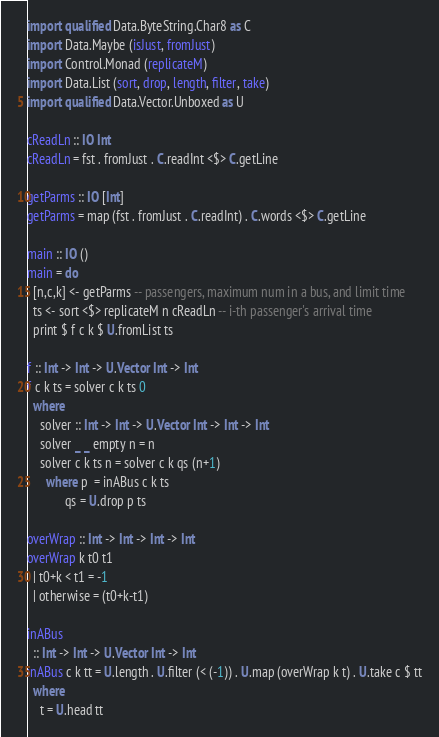Convert code to text. <code><loc_0><loc_0><loc_500><loc_500><_Haskell_>import qualified Data.ByteString.Char8 as C
import Data.Maybe (isJust, fromJust)
import Control.Monad (replicateM)
import Data.List (sort, drop, length, filter, take)
import qualified Data.Vector.Unboxed as U

cReadLn :: IO Int
cReadLn = fst . fromJust . C.readInt <$> C.getLine

getParms :: IO [Int]
getParms = map (fst . fromJust . C.readInt) . C.words <$> C.getLine

main :: IO ()
main = do
  [n,c,k] <- getParms -- passengers, maximum num in a bus, and limit time
  ts <- sort <$> replicateM n cReadLn -- i-th passenger's arrival time
  print $ f c k $ U.fromList ts

f :: Int -> Int -> U.Vector Int -> Int
f c k ts = solver c k ts 0
  where
    solver :: Int -> Int -> U.Vector Int -> Int -> Int
    solver _ _ empty n = n
    solver c k ts n = solver c k qs (n+1)
      where p  = inABus c k ts
            qs = U.drop p ts

overWrap :: Int -> Int -> Int -> Int
overWrap k t0 t1
  | t0+k < t1 = -1
  | otherwise = (t0+k-t1)

inABus 
  :: Int -> Int -> U.Vector Int -> Int
inABus c k tt = U.length . U.filter (< (-1)) . U.map (overWrap k t) . U.take c $ tt
  where
    t = U.head tt</code> 